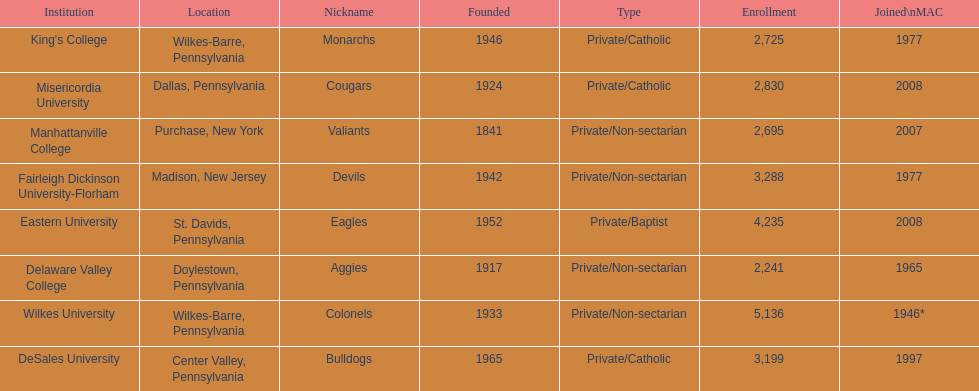Name each institution with enrollment numbers above 4,000? Eastern University, Wilkes University. 